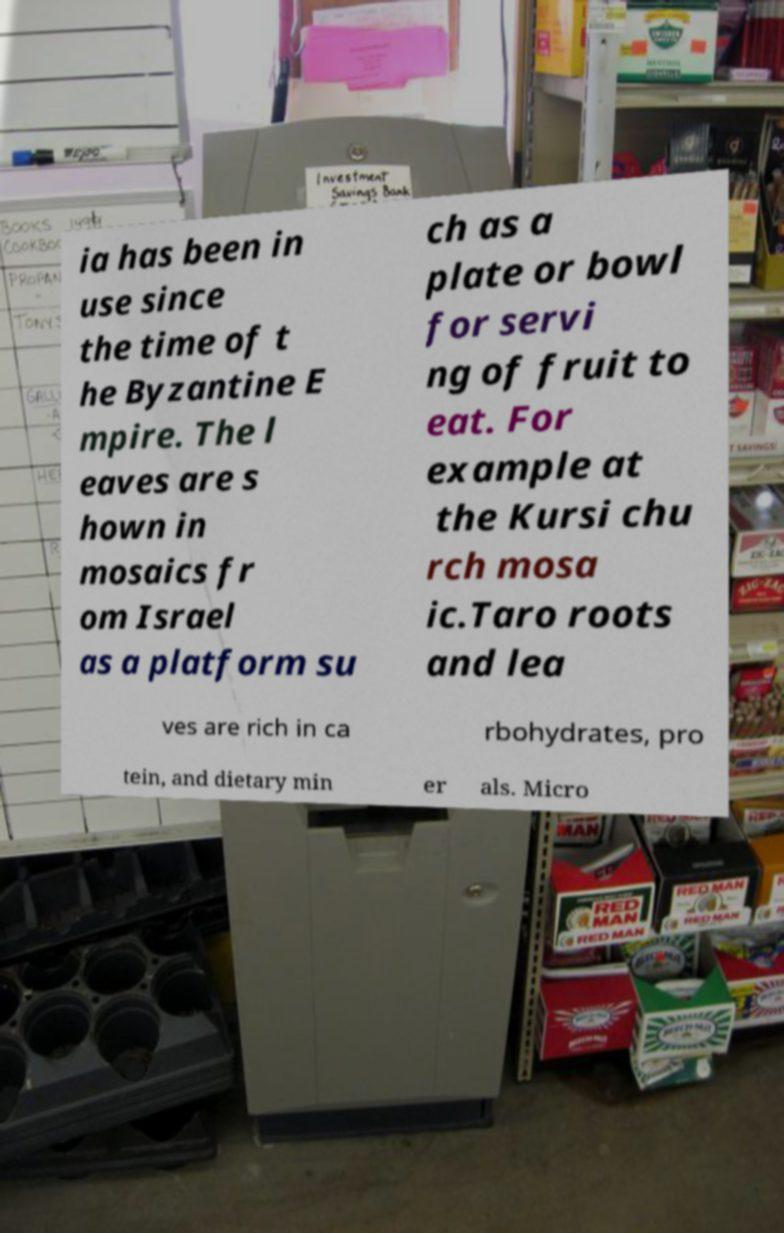Can you read and provide the text displayed in the image?This photo seems to have some interesting text. Can you extract and type it out for me? ia has been in use since the time of t he Byzantine E mpire. The l eaves are s hown in mosaics fr om Israel as a platform su ch as a plate or bowl for servi ng of fruit to eat. For example at the Kursi chu rch mosa ic.Taro roots and lea ves are rich in ca rbohydrates, pro tein, and dietary min er als. Micro 